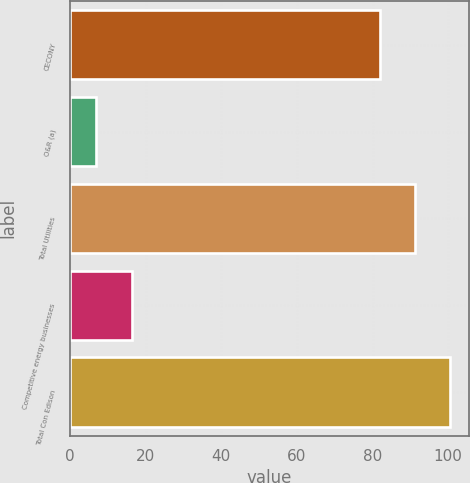Convert chart to OTSL. <chart><loc_0><loc_0><loc_500><loc_500><bar_chart><fcel>CECONY<fcel>O&R (a)<fcel>Total Utilities<fcel>Competitive energy businesses<fcel>Total Con Edison<nl><fcel>82<fcel>7<fcel>91.3<fcel>16.3<fcel>100.6<nl></chart> 